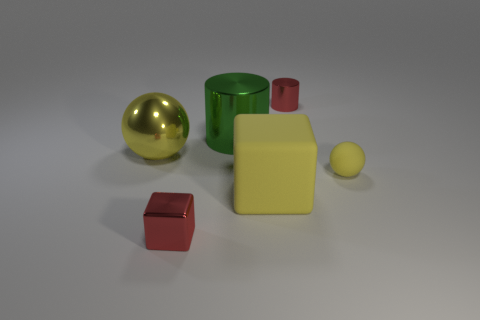Add 3 green metal objects. How many objects exist? 9 Subtract all cubes. How many objects are left? 4 Subtract all balls. Subtract all red objects. How many objects are left? 2 Add 3 yellow metal spheres. How many yellow metal spheres are left? 4 Add 3 large blue rubber cubes. How many large blue rubber cubes exist? 3 Subtract 0 cyan cylinders. How many objects are left? 6 